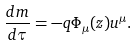Convert formula to latex. <formula><loc_0><loc_0><loc_500><loc_500>\frac { d m } { d \tau } = - q \Phi _ { \mu } ( z ) u ^ { \mu } .</formula> 